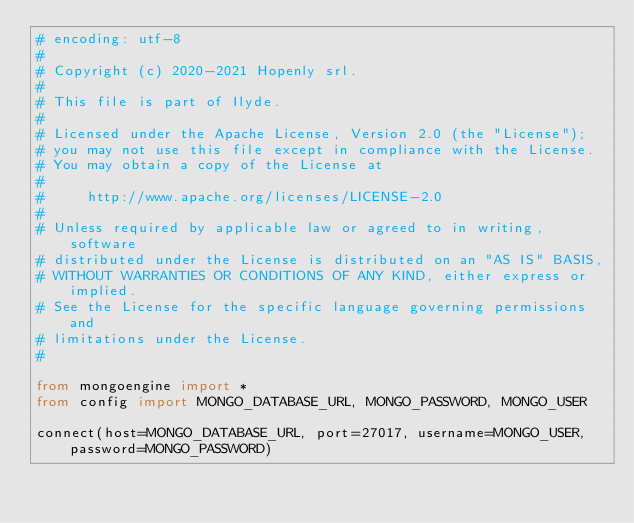<code> <loc_0><loc_0><loc_500><loc_500><_Python_># encoding: utf-8
#
# Copyright (c) 2020-2021 Hopenly srl.
#
# This file is part of Ilyde.
#
# Licensed under the Apache License, Version 2.0 (the "License");
# you may not use this file except in compliance with the License.
# You may obtain a copy of the License at
#
#     http://www.apache.org/licenses/LICENSE-2.0
#
# Unless required by applicable law or agreed to in writing, software
# distributed under the License is distributed on an "AS IS" BASIS,
# WITHOUT WARRANTIES OR CONDITIONS OF ANY KIND, either express or implied.
# See the License for the specific language governing permissions and
# limitations under the License.
#

from mongoengine import *
from config import MONGO_DATABASE_URL, MONGO_PASSWORD, MONGO_USER

connect(host=MONGO_DATABASE_URL, port=27017, username=MONGO_USER, password=MONGO_PASSWORD)
</code> 